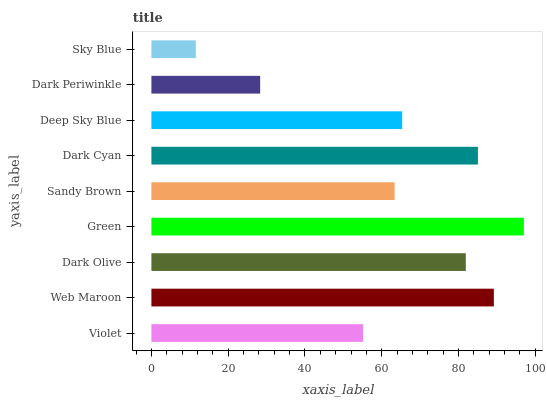Is Sky Blue the minimum?
Answer yes or no. Yes. Is Green the maximum?
Answer yes or no. Yes. Is Web Maroon the minimum?
Answer yes or no. No. Is Web Maroon the maximum?
Answer yes or no. No. Is Web Maroon greater than Violet?
Answer yes or no. Yes. Is Violet less than Web Maroon?
Answer yes or no. Yes. Is Violet greater than Web Maroon?
Answer yes or no. No. Is Web Maroon less than Violet?
Answer yes or no. No. Is Deep Sky Blue the high median?
Answer yes or no. Yes. Is Deep Sky Blue the low median?
Answer yes or no. Yes. Is Dark Cyan the high median?
Answer yes or no. No. Is Sandy Brown the low median?
Answer yes or no. No. 